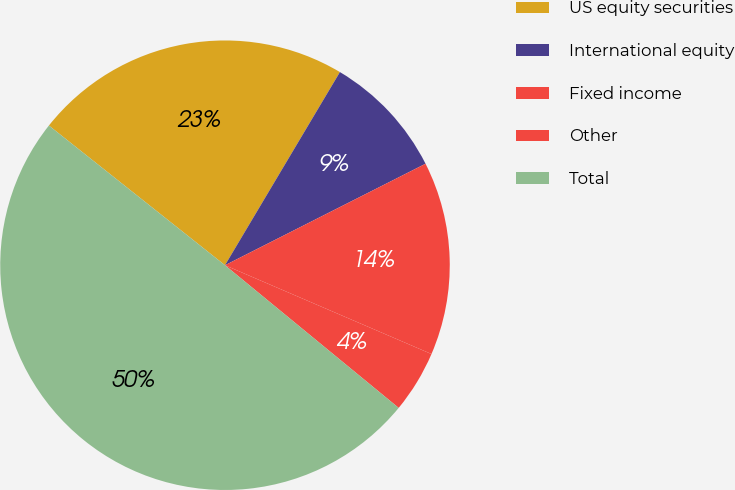Convert chart to OTSL. <chart><loc_0><loc_0><loc_500><loc_500><pie_chart><fcel>US equity securities<fcel>International equity<fcel>Fixed income<fcel>Other<fcel>Total<nl><fcel>22.87%<fcel>9.0%<fcel>13.92%<fcel>4.48%<fcel>49.73%<nl></chart> 